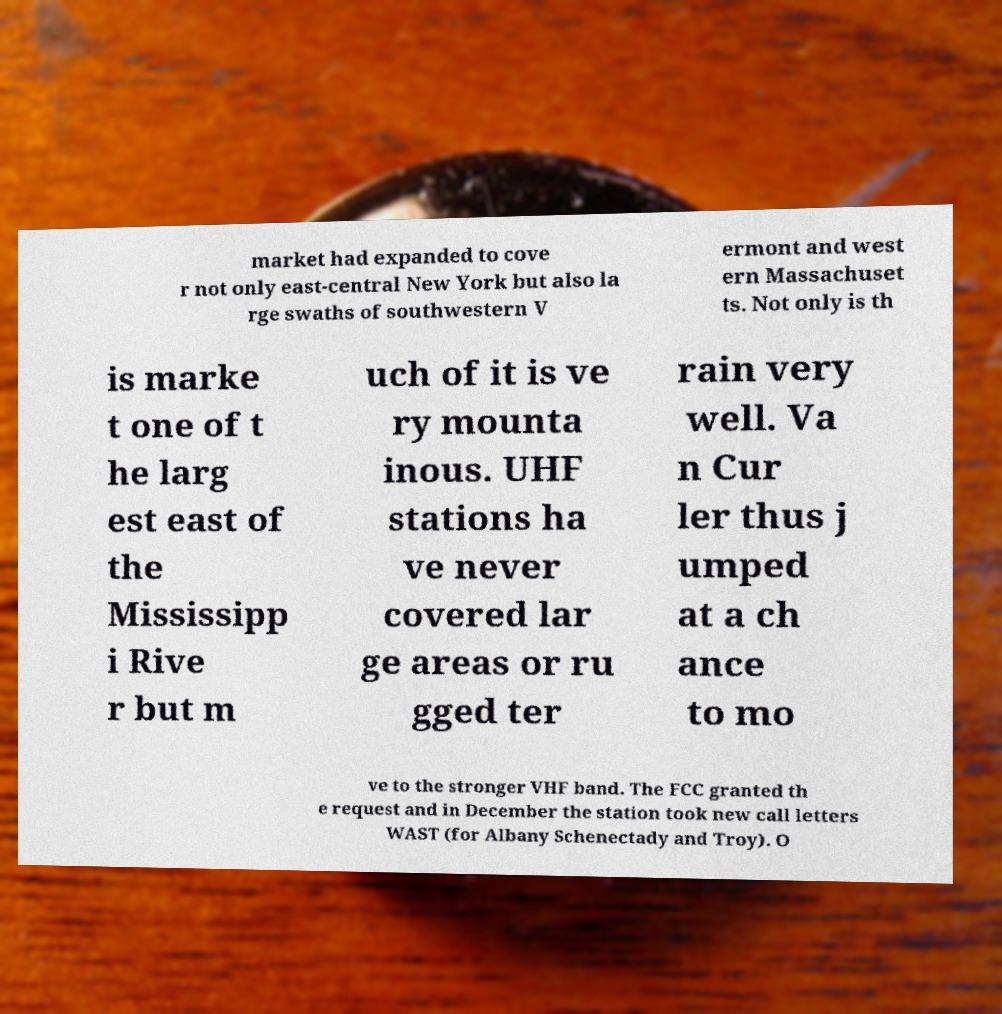Please identify and transcribe the text found in this image. market had expanded to cove r not only east-central New York but also la rge swaths of southwestern V ermont and west ern Massachuset ts. Not only is th is marke t one of t he larg est east of the Mississipp i Rive r but m uch of it is ve ry mounta inous. UHF stations ha ve never covered lar ge areas or ru gged ter rain very well. Va n Cur ler thus j umped at a ch ance to mo ve to the stronger VHF band. The FCC granted th e request and in December the station took new call letters WAST (for Albany Schenectady and Troy). O 